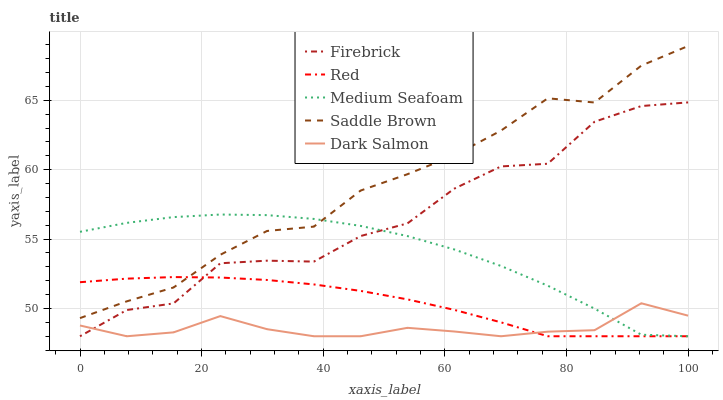Does Dark Salmon have the minimum area under the curve?
Answer yes or no. Yes. Does Saddle Brown have the maximum area under the curve?
Answer yes or no. Yes. Does Medium Seafoam have the minimum area under the curve?
Answer yes or no. No. Does Medium Seafoam have the maximum area under the curve?
Answer yes or no. No. Is Red the smoothest?
Answer yes or no. Yes. Is Firebrick the roughest?
Answer yes or no. Yes. Is Dark Salmon the smoothest?
Answer yes or no. No. Is Dark Salmon the roughest?
Answer yes or no. No. Does Firebrick have the lowest value?
Answer yes or no. Yes. Does Saddle Brown have the lowest value?
Answer yes or no. No. Does Saddle Brown have the highest value?
Answer yes or no. Yes. Does Medium Seafoam have the highest value?
Answer yes or no. No. Is Firebrick less than Saddle Brown?
Answer yes or no. Yes. Is Saddle Brown greater than Firebrick?
Answer yes or no. Yes. Does Medium Seafoam intersect Red?
Answer yes or no. Yes. Is Medium Seafoam less than Red?
Answer yes or no. No. Is Medium Seafoam greater than Red?
Answer yes or no. No. Does Firebrick intersect Saddle Brown?
Answer yes or no. No. 